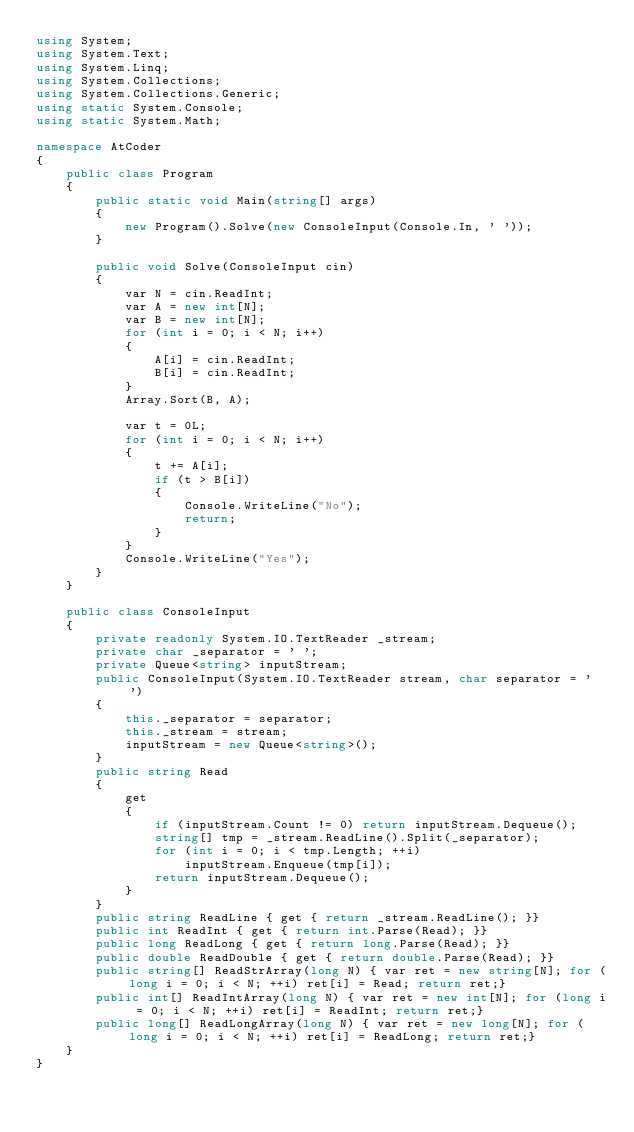<code> <loc_0><loc_0><loc_500><loc_500><_C#_>using System;
using System.Text;
using System.Linq;
using System.Collections;
using System.Collections.Generic;
using static System.Console;
using static System.Math;

namespace AtCoder
{
    public class Program
    {
        public static void Main(string[] args)
        {
            new Program().Solve(new ConsoleInput(Console.In, ' '));
        }

        public void Solve(ConsoleInput cin)
        {
            var N = cin.ReadInt;
            var A = new int[N];
            var B = new int[N];
            for (int i = 0; i < N; i++)
            {
                A[i] = cin.ReadInt;
                B[i] = cin.ReadInt;
            }
            Array.Sort(B, A);

            var t = 0L;
            for (int i = 0; i < N; i++)
            {
                t += A[i];
                if (t > B[i])
                {
                    Console.WriteLine("No");
                    return; 
                }
            }
            Console.WriteLine("Yes");
        }
    }

    public class ConsoleInput
    {
        private readonly System.IO.TextReader _stream;
        private char _separator = ' ';
        private Queue<string> inputStream;
        public ConsoleInput(System.IO.TextReader stream, char separator = ' ')
        {
            this._separator = separator;
            this._stream = stream;
            inputStream = new Queue<string>();
        }
        public string Read
        {
            get
            {
                if (inputStream.Count != 0) return inputStream.Dequeue();
                string[] tmp = _stream.ReadLine().Split(_separator);
                for (int i = 0; i < tmp.Length; ++i)
                    inputStream.Enqueue(tmp[i]);
                return inputStream.Dequeue();
            }
        }
        public string ReadLine { get { return _stream.ReadLine(); }}
        public int ReadInt { get { return int.Parse(Read); }}
        public long ReadLong { get { return long.Parse(Read); }}
        public double ReadDouble { get { return double.Parse(Read); }}
        public string[] ReadStrArray(long N) { var ret = new string[N]; for (long i = 0; i < N; ++i) ret[i] = Read; return ret;}
        public int[] ReadIntArray(long N) { var ret = new int[N]; for (long i = 0; i < N; ++i) ret[i] = ReadInt; return ret;}
        public long[] ReadLongArray(long N) { var ret = new long[N]; for (long i = 0; i < N; ++i) ret[i] = ReadLong; return ret;}
    }
}
</code> 